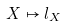Convert formula to latex. <formula><loc_0><loc_0><loc_500><loc_500>X \mapsto l _ { X }</formula> 